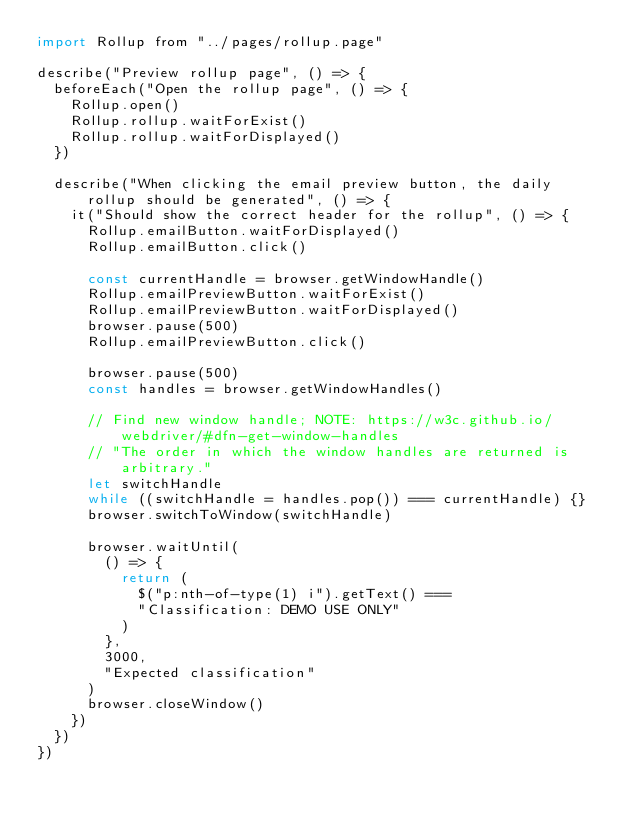<code> <loc_0><loc_0><loc_500><loc_500><_JavaScript_>import Rollup from "../pages/rollup.page"

describe("Preview rollup page", () => {
  beforeEach("Open the rollup page", () => {
    Rollup.open()
    Rollup.rollup.waitForExist()
    Rollup.rollup.waitForDisplayed()
  })

  describe("When clicking the email preview button, the daily rollup should be generated", () => {
    it("Should show the correct header for the rollup", () => {
      Rollup.emailButton.waitForDisplayed()
      Rollup.emailButton.click()

      const currentHandle = browser.getWindowHandle()
      Rollup.emailPreviewButton.waitForExist()
      Rollup.emailPreviewButton.waitForDisplayed()
      browser.pause(500)
      Rollup.emailPreviewButton.click()

      browser.pause(500)
      const handles = browser.getWindowHandles()

      // Find new window handle; NOTE: https://w3c.github.io/webdriver/#dfn-get-window-handles
      // "The order in which the window handles are returned is arbitrary."
      let switchHandle
      while ((switchHandle = handles.pop()) === currentHandle) {}
      browser.switchToWindow(switchHandle)

      browser.waitUntil(
        () => {
          return (
            $("p:nth-of-type(1) i").getText() ===
            "Classification: DEMO USE ONLY"
          )
        },
        3000,
        "Expected classification"
      )
      browser.closeWindow()
    })
  })
})
</code> 